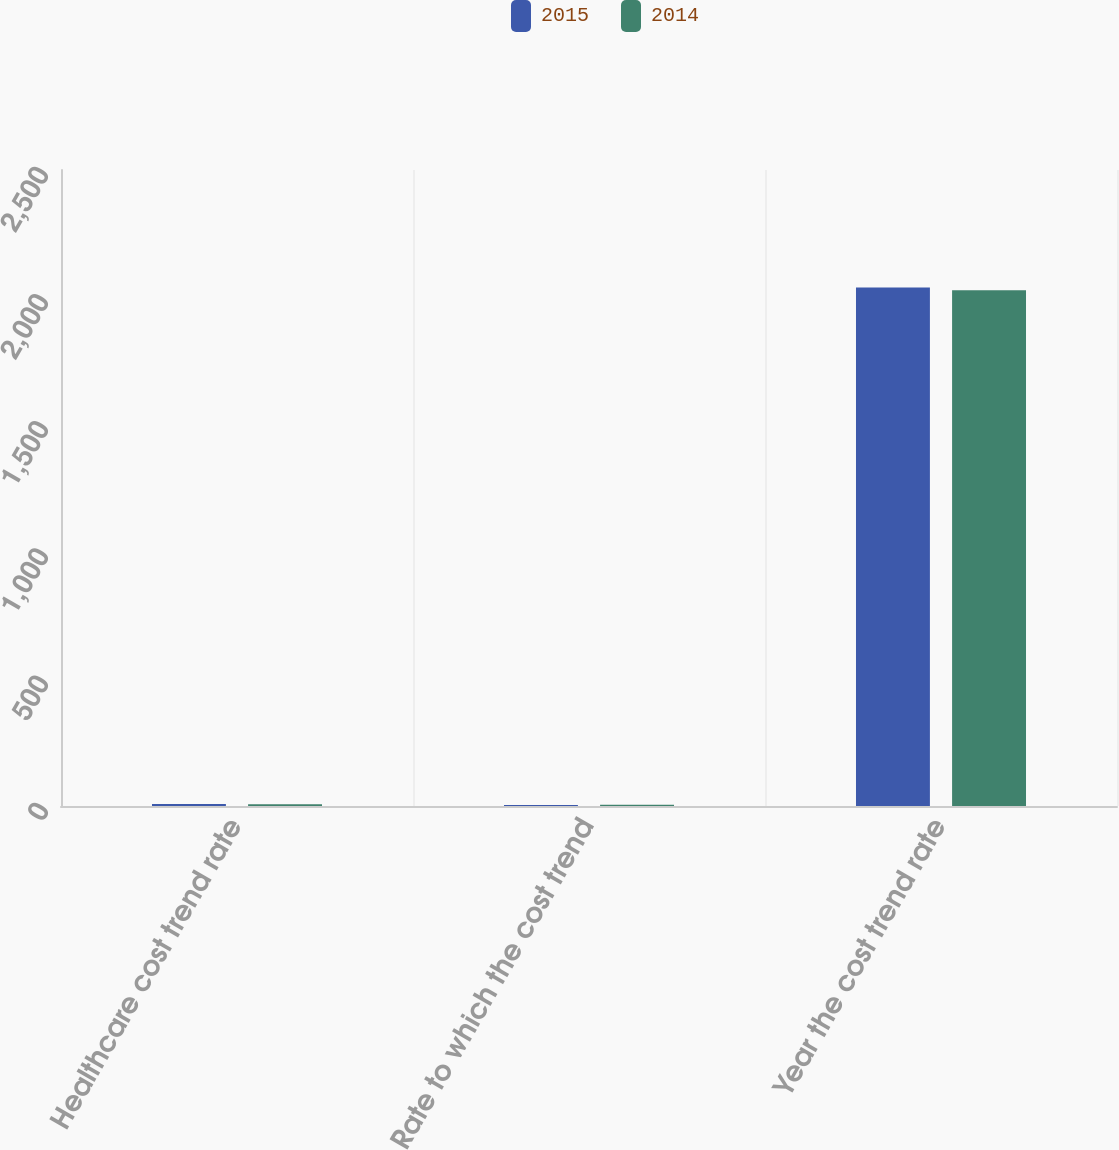Convert chart. <chart><loc_0><loc_0><loc_500><loc_500><stacked_bar_chart><ecel><fcel>Healthcare cost trend rate<fcel>Rate to which the cost trend<fcel>Year the cost trend rate<nl><fcel>2015<fcel>7.4<fcel>4.4<fcel>2038<nl><fcel>2014<fcel>6.8<fcel>4.5<fcel>2027<nl></chart> 